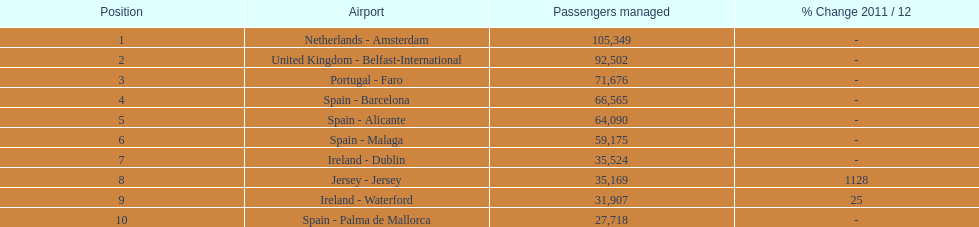Which airport has the least amount of passengers going through london southend airport? Spain - Palma de Mallorca. 